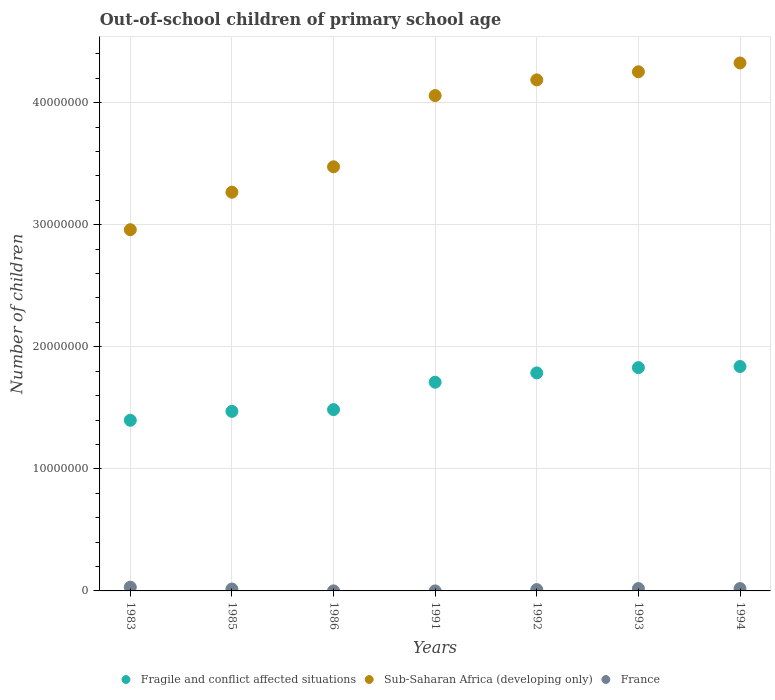How many different coloured dotlines are there?
Offer a terse response. 3. What is the number of out-of-school children in Sub-Saharan Africa (developing only) in 1993?
Offer a terse response. 4.25e+07. Across all years, what is the maximum number of out-of-school children in Sub-Saharan Africa (developing only)?
Your answer should be compact. 4.32e+07. Across all years, what is the minimum number of out-of-school children in France?
Provide a short and direct response. 245. What is the total number of out-of-school children in France in the graph?
Give a very brief answer. 9.63e+05. What is the difference between the number of out-of-school children in Sub-Saharan Africa (developing only) in 1983 and that in 1986?
Keep it short and to the point. -5.15e+06. What is the difference between the number of out-of-school children in Fragile and conflict affected situations in 1992 and the number of out-of-school children in France in 1983?
Give a very brief answer. 1.76e+07. What is the average number of out-of-school children in Sub-Saharan Africa (developing only) per year?
Keep it short and to the point. 3.79e+07. In the year 1991, what is the difference between the number of out-of-school children in Fragile and conflict affected situations and number of out-of-school children in France?
Your response must be concise. 1.71e+07. What is the ratio of the number of out-of-school children in Sub-Saharan Africa (developing only) in 1991 to that in 1992?
Make the answer very short. 0.97. What is the difference between the highest and the second highest number of out-of-school children in Sub-Saharan Africa (developing only)?
Your answer should be very brief. 7.20e+05. What is the difference between the highest and the lowest number of out-of-school children in Fragile and conflict affected situations?
Your response must be concise. 4.41e+06. In how many years, is the number of out-of-school children in Sub-Saharan Africa (developing only) greater than the average number of out-of-school children in Sub-Saharan Africa (developing only) taken over all years?
Your answer should be very brief. 4. Does the graph contain grids?
Your response must be concise. Yes. How are the legend labels stacked?
Offer a terse response. Horizontal. What is the title of the graph?
Keep it short and to the point. Out-of-school children of primary school age. Does "South Asia" appear as one of the legend labels in the graph?
Provide a short and direct response. No. What is the label or title of the X-axis?
Keep it short and to the point. Years. What is the label or title of the Y-axis?
Provide a succinct answer. Number of children. What is the Number of children in Fragile and conflict affected situations in 1983?
Make the answer very short. 1.40e+07. What is the Number of children in Sub-Saharan Africa (developing only) in 1983?
Provide a short and direct response. 2.96e+07. What is the Number of children in France in 1983?
Your response must be concise. 3.06e+05. What is the Number of children of Fragile and conflict affected situations in 1985?
Make the answer very short. 1.47e+07. What is the Number of children in Sub-Saharan Africa (developing only) in 1985?
Provide a short and direct response. 3.27e+07. What is the Number of children of France in 1985?
Provide a short and direct response. 1.56e+05. What is the Number of children in Fragile and conflict affected situations in 1986?
Offer a terse response. 1.49e+07. What is the Number of children in Sub-Saharan Africa (developing only) in 1986?
Offer a very short reply. 3.47e+07. What is the Number of children in France in 1986?
Your answer should be very brief. 2432. What is the Number of children in Fragile and conflict affected situations in 1991?
Provide a short and direct response. 1.71e+07. What is the Number of children of Sub-Saharan Africa (developing only) in 1991?
Offer a terse response. 4.06e+07. What is the Number of children in France in 1991?
Keep it short and to the point. 245. What is the Number of children in Fragile and conflict affected situations in 1992?
Your answer should be very brief. 1.79e+07. What is the Number of children of Sub-Saharan Africa (developing only) in 1992?
Keep it short and to the point. 4.19e+07. What is the Number of children of France in 1992?
Ensure brevity in your answer.  1.08e+05. What is the Number of children of Fragile and conflict affected situations in 1993?
Provide a succinct answer. 1.83e+07. What is the Number of children of Sub-Saharan Africa (developing only) in 1993?
Make the answer very short. 4.25e+07. What is the Number of children of France in 1993?
Your answer should be compact. 1.94e+05. What is the Number of children of Fragile and conflict affected situations in 1994?
Ensure brevity in your answer.  1.84e+07. What is the Number of children of Sub-Saharan Africa (developing only) in 1994?
Offer a terse response. 4.32e+07. What is the Number of children in France in 1994?
Provide a succinct answer. 1.96e+05. Across all years, what is the maximum Number of children in Fragile and conflict affected situations?
Offer a very short reply. 1.84e+07. Across all years, what is the maximum Number of children of Sub-Saharan Africa (developing only)?
Provide a succinct answer. 4.32e+07. Across all years, what is the maximum Number of children of France?
Provide a succinct answer. 3.06e+05. Across all years, what is the minimum Number of children in Fragile and conflict affected situations?
Keep it short and to the point. 1.40e+07. Across all years, what is the minimum Number of children of Sub-Saharan Africa (developing only)?
Give a very brief answer. 2.96e+07. Across all years, what is the minimum Number of children in France?
Ensure brevity in your answer.  245. What is the total Number of children of Fragile and conflict affected situations in the graph?
Make the answer very short. 1.15e+08. What is the total Number of children of Sub-Saharan Africa (developing only) in the graph?
Your answer should be compact. 2.65e+08. What is the total Number of children in France in the graph?
Give a very brief answer. 9.63e+05. What is the difference between the Number of children in Fragile and conflict affected situations in 1983 and that in 1985?
Provide a succinct answer. -7.29e+05. What is the difference between the Number of children in Sub-Saharan Africa (developing only) in 1983 and that in 1985?
Provide a succinct answer. -3.07e+06. What is the difference between the Number of children of France in 1983 and that in 1985?
Make the answer very short. 1.50e+05. What is the difference between the Number of children in Fragile and conflict affected situations in 1983 and that in 1986?
Ensure brevity in your answer.  -8.75e+05. What is the difference between the Number of children in Sub-Saharan Africa (developing only) in 1983 and that in 1986?
Your response must be concise. -5.15e+06. What is the difference between the Number of children in France in 1983 and that in 1986?
Your answer should be compact. 3.04e+05. What is the difference between the Number of children of Fragile and conflict affected situations in 1983 and that in 1991?
Your answer should be very brief. -3.12e+06. What is the difference between the Number of children of Sub-Saharan Africa (developing only) in 1983 and that in 1991?
Offer a very short reply. -1.10e+07. What is the difference between the Number of children of France in 1983 and that in 1991?
Offer a very short reply. 3.06e+05. What is the difference between the Number of children in Fragile and conflict affected situations in 1983 and that in 1992?
Make the answer very short. -3.88e+06. What is the difference between the Number of children of Sub-Saharan Africa (developing only) in 1983 and that in 1992?
Offer a very short reply. -1.23e+07. What is the difference between the Number of children of France in 1983 and that in 1992?
Offer a very short reply. 1.98e+05. What is the difference between the Number of children of Fragile and conflict affected situations in 1983 and that in 1993?
Keep it short and to the point. -4.31e+06. What is the difference between the Number of children in Sub-Saharan Africa (developing only) in 1983 and that in 1993?
Your response must be concise. -1.29e+07. What is the difference between the Number of children in France in 1983 and that in 1993?
Your response must be concise. 1.12e+05. What is the difference between the Number of children in Fragile and conflict affected situations in 1983 and that in 1994?
Offer a terse response. -4.41e+06. What is the difference between the Number of children in Sub-Saharan Africa (developing only) in 1983 and that in 1994?
Keep it short and to the point. -1.37e+07. What is the difference between the Number of children in France in 1983 and that in 1994?
Make the answer very short. 1.10e+05. What is the difference between the Number of children of Fragile and conflict affected situations in 1985 and that in 1986?
Ensure brevity in your answer.  -1.45e+05. What is the difference between the Number of children in Sub-Saharan Africa (developing only) in 1985 and that in 1986?
Keep it short and to the point. -2.08e+06. What is the difference between the Number of children in France in 1985 and that in 1986?
Ensure brevity in your answer.  1.54e+05. What is the difference between the Number of children in Fragile and conflict affected situations in 1985 and that in 1991?
Your answer should be very brief. -2.39e+06. What is the difference between the Number of children of Sub-Saharan Africa (developing only) in 1985 and that in 1991?
Ensure brevity in your answer.  -7.92e+06. What is the difference between the Number of children of France in 1985 and that in 1991?
Ensure brevity in your answer.  1.56e+05. What is the difference between the Number of children of Fragile and conflict affected situations in 1985 and that in 1992?
Your response must be concise. -3.15e+06. What is the difference between the Number of children of Sub-Saharan Africa (developing only) in 1985 and that in 1992?
Offer a terse response. -9.20e+06. What is the difference between the Number of children of France in 1985 and that in 1992?
Offer a very short reply. 4.80e+04. What is the difference between the Number of children of Fragile and conflict affected situations in 1985 and that in 1993?
Your response must be concise. -3.59e+06. What is the difference between the Number of children of Sub-Saharan Africa (developing only) in 1985 and that in 1993?
Keep it short and to the point. -9.87e+06. What is the difference between the Number of children of France in 1985 and that in 1993?
Your answer should be very brief. -3.82e+04. What is the difference between the Number of children in Fragile and conflict affected situations in 1985 and that in 1994?
Make the answer very short. -3.68e+06. What is the difference between the Number of children of Sub-Saharan Africa (developing only) in 1985 and that in 1994?
Offer a very short reply. -1.06e+07. What is the difference between the Number of children in France in 1985 and that in 1994?
Your response must be concise. -3.97e+04. What is the difference between the Number of children of Fragile and conflict affected situations in 1986 and that in 1991?
Your answer should be very brief. -2.24e+06. What is the difference between the Number of children in Sub-Saharan Africa (developing only) in 1986 and that in 1991?
Keep it short and to the point. -5.83e+06. What is the difference between the Number of children of France in 1986 and that in 1991?
Your answer should be compact. 2187. What is the difference between the Number of children in Fragile and conflict affected situations in 1986 and that in 1992?
Your answer should be compact. -3.01e+06. What is the difference between the Number of children in Sub-Saharan Africa (developing only) in 1986 and that in 1992?
Provide a succinct answer. -7.12e+06. What is the difference between the Number of children in France in 1986 and that in 1992?
Your answer should be very brief. -1.06e+05. What is the difference between the Number of children of Fragile and conflict affected situations in 1986 and that in 1993?
Your answer should be very brief. -3.44e+06. What is the difference between the Number of children in Sub-Saharan Africa (developing only) in 1986 and that in 1993?
Your response must be concise. -7.78e+06. What is the difference between the Number of children in France in 1986 and that in 1993?
Provide a short and direct response. -1.92e+05. What is the difference between the Number of children in Fragile and conflict affected situations in 1986 and that in 1994?
Provide a short and direct response. -3.53e+06. What is the difference between the Number of children of Sub-Saharan Africa (developing only) in 1986 and that in 1994?
Keep it short and to the point. -8.50e+06. What is the difference between the Number of children in France in 1986 and that in 1994?
Ensure brevity in your answer.  -1.93e+05. What is the difference between the Number of children in Fragile and conflict affected situations in 1991 and that in 1992?
Your answer should be very brief. -7.63e+05. What is the difference between the Number of children of Sub-Saharan Africa (developing only) in 1991 and that in 1992?
Make the answer very short. -1.28e+06. What is the difference between the Number of children of France in 1991 and that in 1992?
Keep it short and to the point. -1.08e+05. What is the difference between the Number of children in Fragile and conflict affected situations in 1991 and that in 1993?
Offer a very short reply. -1.20e+06. What is the difference between the Number of children of Sub-Saharan Africa (developing only) in 1991 and that in 1993?
Make the answer very short. -1.95e+06. What is the difference between the Number of children in France in 1991 and that in 1993?
Your answer should be very brief. -1.94e+05. What is the difference between the Number of children in Fragile and conflict affected situations in 1991 and that in 1994?
Your response must be concise. -1.29e+06. What is the difference between the Number of children in Sub-Saharan Africa (developing only) in 1991 and that in 1994?
Provide a succinct answer. -2.67e+06. What is the difference between the Number of children of France in 1991 and that in 1994?
Give a very brief answer. -1.96e+05. What is the difference between the Number of children in Fragile and conflict affected situations in 1992 and that in 1993?
Keep it short and to the point. -4.33e+05. What is the difference between the Number of children of Sub-Saharan Africa (developing only) in 1992 and that in 1993?
Keep it short and to the point. -6.66e+05. What is the difference between the Number of children of France in 1992 and that in 1993?
Provide a succinct answer. -8.62e+04. What is the difference between the Number of children in Fragile and conflict affected situations in 1992 and that in 1994?
Your answer should be compact. -5.24e+05. What is the difference between the Number of children of Sub-Saharan Africa (developing only) in 1992 and that in 1994?
Make the answer very short. -1.39e+06. What is the difference between the Number of children of France in 1992 and that in 1994?
Offer a terse response. -8.76e+04. What is the difference between the Number of children in Fragile and conflict affected situations in 1993 and that in 1994?
Offer a terse response. -9.04e+04. What is the difference between the Number of children in Sub-Saharan Africa (developing only) in 1993 and that in 1994?
Ensure brevity in your answer.  -7.20e+05. What is the difference between the Number of children of France in 1993 and that in 1994?
Keep it short and to the point. -1459. What is the difference between the Number of children of Fragile and conflict affected situations in 1983 and the Number of children of Sub-Saharan Africa (developing only) in 1985?
Your response must be concise. -1.87e+07. What is the difference between the Number of children of Fragile and conflict affected situations in 1983 and the Number of children of France in 1985?
Keep it short and to the point. 1.38e+07. What is the difference between the Number of children in Sub-Saharan Africa (developing only) in 1983 and the Number of children in France in 1985?
Your answer should be compact. 2.94e+07. What is the difference between the Number of children in Fragile and conflict affected situations in 1983 and the Number of children in Sub-Saharan Africa (developing only) in 1986?
Provide a succinct answer. -2.08e+07. What is the difference between the Number of children in Fragile and conflict affected situations in 1983 and the Number of children in France in 1986?
Your answer should be compact. 1.40e+07. What is the difference between the Number of children of Sub-Saharan Africa (developing only) in 1983 and the Number of children of France in 1986?
Your answer should be very brief. 2.96e+07. What is the difference between the Number of children of Fragile and conflict affected situations in 1983 and the Number of children of Sub-Saharan Africa (developing only) in 1991?
Offer a very short reply. -2.66e+07. What is the difference between the Number of children of Fragile and conflict affected situations in 1983 and the Number of children of France in 1991?
Provide a succinct answer. 1.40e+07. What is the difference between the Number of children of Sub-Saharan Africa (developing only) in 1983 and the Number of children of France in 1991?
Offer a terse response. 2.96e+07. What is the difference between the Number of children of Fragile and conflict affected situations in 1983 and the Number of children of Sub-Saharan Africa (developing only) in 1992?
Your answer should be compact. -2.79e+07. What is the difference between the Number of children of Fragile and conflict affected situations in 1983 and the Number of children of France in 1992?
Your answer should be very brief. 1.39e+07. What is the difference between the Number of children in Sub-Saharan Africa (developing only) in 1983 and the Number of children in France in 1992?
Offer a terse response. 2.95e+07. What is the difference between the Number of children in Fragile and conflict affected situations in 1983 and the Number of children in Sub-Saharan Africa (developing only) in 1993?
Ensure brevity in your answer.  -2.85e+07. What is the difference between the Number of children of Fragile and conflict affected situations in 1983 and the Number of children of France in 1993?
Your response must be concise. 1.38e+07. What is the difference between the Number of children of Sub-Saharan Africa (developing only) in 1983 and the Number of children of France in 1993?
Offer a terse response. 2.94e+07. What is the difference between the Number of children of Fragile and conflict affected situations in 1983 and the Number of children of Sub-Saharan Africa (developing only) in 1994?
Your response must be concise. -2.93e+07. What is the difference between the Number of children of Fragile and conflict affected situations in 1983 and the Number of children of France in 1994?
Provide a succinct answer. 1.38e+07. What is the difference between the Number of children of Sub-Saharan Africa (developing only) in 1983 and the Number of children of France in 1994?
Make the answer very short. 2.94e+07. What is the difference between the Number of children in Fragile and conflict affected situations in 1985 and the Number of children in Sub-Saharan Africa (developing only) in 1986?
Your answer should be very brief. -2.00e+07. What is the difference between the Number of children of Fragile and conflict affected situations in 1985 and the Number of children of France in 1986?
Keep it short and to the point. 1.47e+07. What is the difference between the Number of children of Sub-Saharan Africa (developing only) in 1985 and the Number of children of France in 1986?
Your response must be concise. 3.27e+07. What is the difference between the Number of children of Fragile and conflict affected situations in 1985 and the Number of children of Sub-Saharan Africa (developing only) in 1991?
Offer a very short reply. -2.59e+07. What is the difference between the Number of children of Fragile and conflict affected situations in 1985 and the Number of children of France in 1991?
Your answer should be very brief. 1.47e+07. What is the difference between the Number of children of Sub-Saharan Africa (developing only) in 1985 and the Number of children of France in 1991?
Your answer should be compact. 3.27e+07. What is the difference between the Number of children of Fragile and conflict affected situations in 1985 and the Number of children of Sub-Saharan Africa (developing only) in 1992?
Offer a terse response. -2.72e+07. What is the difference between the Number of children in Fragile and conflict affected situations in 1985 and the Number of children in France in 1992?
Offer a terse response. 1.46e+07. What is the difference between the Number of children in Sub-Saharan Africa (developing only) in 1985 and the Number of children in France in 1992?
Provide a short and direct response. 3.26e+07. What is the difference between the Number of children in Fragile and conflict affected situations in 1985 and the Number of children in Sub-Saharan Africa (developing only) in 1993?
Your answer should be very brief. -2.78e+07. What is the difference between the Number of children in Fragile and conflict affected situations in 1985 and the Number of children in France in 1993?
Your response must be concise. 1.45e+07. What is the difference between the Number of children of Sub-Saharan Africa (developing only) in 1985 and the Number of children of France in 1993?
Ensure brevity in your answer.  3.25e+07. What is the difference between the Number of children in Fragile and conflict affected situations in 1985 and the Number of children in Sub-Saharan Africa (developing only) in 1994?
Make the answer very short. -2.85e+07. What is the difference between the Number of children of Fragile and conflict affected situations in 1985 and the Number of children of France in 1994?
Make the answer very short. 1.45e+07. What is the difference between the Number of children of Sub-Saharan Africa (developing only) in 1985 and the Number of children of France in 1994?
Offer a terse response. 3.25e+07. What is the difference between the Number of children in Fragile and conflict affected situations in 1986 and the Number of children in Sub-Saharan Africa (developing only) in 1991?
Give a very brief answer. -2.57e+07. What is the difference between the Number of children of Fragile and conflict affected situations in 1986 and the Number of children of France in 1991?
Keep it short and to the point. 1.49e+07. What is the difference between the Number of children in Sub-Saharan Africa (developing only) in 1986 and the Number of children in France in 1991?
Your response must be concise. 3.47e+07. What is the difference between the Number of children of Fragile and conflict affected situations in 1986 and the Number of children of Sub-Saharan Africa (developing only) in 1992?
Your answer should be very brief. -2.70e+07. What is the difference between the Number of children in Fragile and conflict affected situations in 1986 and the Number of children in France in 1992?
Offer a very short reply. 1.47e+07. What is the difference between the Number of children in Sub-Saharan Africa (developing only) in 1986 and the Number of children in France in 1992?
Give a very brief answer. 3.46e+07. What is the difference between the Number of children of Fragile and conflict affected situations in 1986 and the Number of children of Sub-Saharan Africa (developing only) in 1993?
Your answer should be very brief. -2.77e+07. What is the difference between the Number of children of Fragile and conflict affected situations in 1986 and the Number of children of France in 1993?
Offer a very short reply. 1.47e+07. What is the difference between the Number of children in Sub-Saharan Africa (developing only) in 1986 and the Number of children in France in 1993?
Your answer should be very brief. 3.46e+07. What is the difference between the Number of children in Fragile and conflict affected situations in 1986 and the Number of children in Sub-Saharan Africa (developing only) in 1994?
Keep it short and to the point. -2.84e+07. What is the difference between the Number of children of Fragile and conflict affected situations in 1986 and the Number of children of France in 1994?
Provide a succinct answer. 1.47e+07. What is the difference between the Number of children in Sub-Saharan Africa (developing only) in 1986 and the Number of children in France in 1994?
Provide a succinct answer. 3.45e+07. What is the difference between the Number of children of Fragile and conflict affected situations in 1991 and the Number of children of Sub-Saharan Africa (developing only) in 1992?
Make the answer very short. -2.48e+07. What is the difference between the Number of children of Fragile and conflict affected situations in 1991 and the Number of children of France in 1992?
Keep it short and to the point. 1.70e+07. What is the difference between the Number of children of Sub-Saharan Africa (developing only) in 1991 and the Number of children of France in 1992?
Provide a short and direct response. 4.05e+07. What is the difference between the Number of children in Fragile and conflict affected situations in 1991 and the Number of children in Sub-Saharan Africa (developing only) in 1993?
Offer a very short reply. -2.54e+07. What is the difference between the Number of children in Fragile and conflict affected situations in 1991 and the Number of children in France in 1993?
Provide a short and direct response. 1.69e+07. What is the difference between the Number of children of Sub-Saharan Africa (developing only) in 1991 and the Number of children of France in 1993?
Provide a short and direct response. 4.04e+07. What is the difference between the Number of children of Fragile and conflict affected situations in 1991 and the Number of children of Sub-Saharan Africa (developing only) in 1994?
Ensure brevity in your answer.  -2.62e+07. What is the difference between the Number of children in Fragile and conflict affected situations in 1991 and the Number of children in France in 1994?
Your answer should be compact. 1.69e+07. What is the difference between the Number of children in Sub-Saharan Africa (developing only) in 1991 and the Number of children in France in 1994?
Keep it short and to the point. 4.04e+07. What is the difference between the Number of children of Fragile and conflict affected situations in 1992 and the Number of children of Sub-Saharan Africa (developing only) in 1993?
Ensure brevity in your answer.  -2.47e+07. What is the difference between the Number of children of Fragile and conflict affected situations in 1992 and the Number of children of France in 1993?
Keep it short and to the point. 1.77e+07. What is the difference between the Number of children of Sub-Saharan Africa (developing only) in 1992 and the Number of children of France in 1993?
Make the answer very short. 4.17e+07. What is the difference between the Number of children in Fragile and conflict affected situations in 1992 and the Number of children in Sub-Saharan Africa (developing only) in 1994?
Your answer should be very brief. -2.54e+07. What is the difference between the Number of children of Fragile and conflict affected situations in 1992 and the Number of children of France in 1994?
Ensure brevity in your answer.  1.77e+07. What is the difference between the Number of children in Sub-Saharan Africa (developing only) in 1992 and the Number of children in France in 1994?
Your answer should be compact. 4.17e+07. What is the difference between the Number of children in Fragile and conflict affected situations in 1993 and the Number of children in Sub-Saharan Africa (developing only) in 1994?
Make the answer very short. -2.50e+07. What is the difference between the Number of children in Fragile and conflict affected situations in 1993 and the Number of children in France in 1994?
Provide a short and direct response. 1.81e+07. What is the difference between the Number of children in Sub-Saharan Africa (developing only) in 1993 and the Number of children in France in 1994?
Ensure brevity in your answer.  4.23e+07. What is the average Number of children in Fragile and conflict affected situations per year?
Offer a very short reply. 1.65e+07. What is the average Number of children in Sub-Saharan Africa (developing only) per year?
Keep it short and to the point. 3.79e+07. What is the average Number of children in France per year?
Give a very brief answer. 1.38e+05. In the year 1983, what is the difference between the Number of children of Fragile and conflict affected situations and Number of children of Sub-Saharan Africa (developing only)?
Offer a terse response. -1.56e+07. In the year 1983, what is the difference between the Number of children in Fragile and conflict affected situations and Number of children in France?
Provide a succinct answer. 1.37e+07. In the year 1983, what is the difference between the Number of children in Sub-Saharan Africa (developing only) and Number of children in France?
Your answer should be very brief. 2.93e+07. In the year 1985, what is the difference between the Number of children of Fragile and conflict affected situations and Number of children of Sub-Saharan Africa (developing only)?
Ensure brevity in your answer.  -1.80e+07. In the year 1985, what is the difference between the Number of children of Fragile and conflict affected situations and Number of children of France?
Your response must be concise. 1.46e+07. In the year 1985, what is the difference between the Number of children of Sub-Saharan Africa (developing only) and Number of children of France?
Ensure brevity in your answer.  3.25e+07. In the year 1986, what is the difference between the Number of children in Fragile and conflict affected situations and Number of children in Sub-Saharan Africa (developing only)?
Ensure brevity in your answer.  -1.99e+07. In the year 1986, what is the difference between the Number of children of Fragile and conflict affected situations and Number of children of France?
Provide a short and direct response. 1.49e+07. In the year 1986, what is the difference between the Number of children in Sub-Saharan Africa (developing only) and Number of children in France?
Provide a short and direct response. 3.47e+07. In the year 1991, what is the difference between the Number of children in Fragile and conflict affected situations and Number of children in Sub-Saharan Africa (developing only)?
Give a very brief answer. -2.35e+07. In the year 1991, what is the difference between the Number of children of Fragile and conflict affected situations and Number of children of France?
Make the answer very short. 1.71e+07. In the year 1991, what is the difference between the Number of children in Sub-Saharan Africa (developing only) and Number of children in France?
Your response must be concise. 4.06e+07. In the year 1992, what is the difference between the Number of children of Fragile and conflict affected situations and Number of children of Sub-Saharan Africa (developing only)?
Offer a terse response. -2.40e+07. In the year 1992, what is the difference between the Number of children of Fragile and conflict affected situations and Number of children of France?
Your response must be concise. 1.78e+07. In the year 1992, what is the difference between the Number of children of Sub-Saharan Africa (developing only) and Number of children of France?
Make the answer very short. 4.18e+07. In the year 1993, what is the difference between the Number of children of Fragile and conflict affected situations and Number of children of Sub-Saharan Africa (developing only)?
Your answer should be very brief. -2.42e+07. In the year 1993, what is the difference between the Number of children in Fragile and conflict affected situations and Number of children in France?
Keep it short and to the point. 1.81e+07. In the year 1993, what is the difference between the Number of children in Sub-Saharan Africa (developing only) and Number of children in France?
Give a very brief answer. 4.23e+07. In the year 1994, what is the difference between the Number of children in Fragile and conflict affected situations and Number of children in Sub-Saharan Africa (developing only)?
Make the answer very short. -2.49e+07. In the year 1994, what is the difference between the Number of children of Fragile and conflict affected situations and Number of children of France?
Give a very brief answer. 1.82e+07. In the year 1994, what is the difference between the Number of children of Sub-Saharan Africa (developing only) and Number of children of France?
Ensure brevity in your answer.  4.31e+07. What is the ratio of the Number of children in Fragile and conflict affected situations in 1983 to that in 1985?
Your answer should be very brief. 0.95. What is the ratio of the Number of children of Sub-Saharan Africa (developing only) in 1983 to that in 1985?
Your response must be concise. 0.91. What is the ratio of the Number of children of France in 1983 to that in 1985?
Offer a terse response. 1.96. What is the ratio of the Number of children in Fragile and conflict affected situations in 1983 to that in 1986?
Offer a very short reply. 0.94. What is the ratio of the Number of children in Sub-Saharan Africa (developing only) in 1983 to that in 1986?
Your response must be concise. 0.85. What is the ratio of the Number of children of France in 1983 to that in 1986?
Provide a short and direct response. 125.91. What is the ratio of the Number of children in Fragile and conflict affected situations in 1983 to that in 1991?
Make the answer very short. 0.82. What is the ratio of the Number of children of Sub-Saharan Africa (developing only) in 1983 to that in 1991?
Your response must be concise. 0.73. What is the ratio of the Number of children in France in 1983 to that in 1991?
Make the answer very short. 1249.9. What is the ratio of the Number of children of Fragile and conflict affected situations in 1983 to that in 1992?
Your answer should be compact. 0.78. What is the ratio of the Number of children of Sub-Saharan Africa (developing only) in 1983 to that in 1992?
Provide a succinct answer. 0.71. What is the ratio of the Number of children of France in 1983 to that in 1992?
Your response must be concise. 2.83. What is the ratio of the Number of children in Fragile and conflict affected situations in 1983 to that in 1993?
Your answer should be very brief. 0.76. What is the ratio of the Number of children in Sub-Saharan Africa (developing only) in 1983 to that in 1993?
Ensure brevity in your answer.  0.7. What is the ratio of the Number of children in France in 1983 to that in 1993?
Your answer should be very brief. 1.58. What is the ratio of the Number of children of Fragile and conflict affected situations in 1983 to that in 1994?
Your answer should be compact. 0.76. What is the ratio of the Number of children of Sub-Saharan Africa (developing only) in 1983 to that in 1994?
Your answer should be very brief. 0.68. What is the ratio of the Number of children of France in 1983 to that in 1994?
Keep it short and to the point. 1.56. What is the ratio of the Number of children of Fragile and conflict affected situations in 1985 to that in 1986?
Ensure brevity in your answer.  0.99. What is the ratio of the Number of children of Sub-Saharan Africa (developing only) in 1985 to that in 1986?
Give a very brief answer. 0.94. What is the ratio of the Number of children in France in 1985 to that in 1986?
Offer a terse response. 64.2. What is the ratio of the Number of children in Fragile and conflict affected situations in 1985 to that in 1991?
Give a very brief answer. 0.86. What is the ratio of the Number of children of Sub-Saharan Africa (developing only) in 1985 to that in 1991?
Your answer should be very brief. 0.8. What is the ratio of the Number of children in France in 1985 to that in 1991?
Give a very brief answer. 637.3. What is the ratio of the Number of children in Fragile and conflict affected situations in 1985 to that in 1992?
Make the answer very short. 0.82. What is the ratio of the Number of children in Sub-Saharan Africa (developing only) in 1985 to that in 1992?
Keep it short and to the point. 0.78. What is the ratio of the Number of children in France in 1985 to that in 1992?
Your answer should be compact. 1.44. What is the ratio of the Number of children in Fragile and conflict affected situations in 1985 to that in 1993?
Give a very brief answer. 0.8. What is the ratio of the Number of children of Sub-Saharan Africa (developing only) in 1985 to that in 1993?
Your answer should be very brief. 0.77. What is the ratio of the Number of children in France in 1985 to that in 1993?
Offer a very short reply. 0.8. What is the ratio of the Number of children of Fragile and conflict affected situations in 1985 to that in 1994?
Provide a succinct answer. 0.8. What is the ratio of the Number of children in Sub-Saharan Africa (developing only) in 1985 to that in 1994?
Your answer should be very brief. 0.76. What is the ratio of the Number of children of France in 1985 to that in 1994?
Provide a short and direct response. 0.8. What is the ratio of the Number of children of Fragile and conflict affected situations in 1986 to that in 1991?
Your answer should be compact. 0.87. What is the ratio of the Number of children of Sub-Saharan Africa (developing only) in 1986 to that in 1991?
Your answer should be compact. 0.86. What is the ratio of the Number of children of France in 1986 to that in 1991?
Offer a very short reply. 9.93. What is the ratio of the Number of children in Fragile and conflict affected situations in 1986 to that in 1992?
Your answer should be very brief. 0.83. What is the ratio of the Number of children of Sub-Saharan Africa (developing only) in 1986 to that in 1992?
Make the answer very short. 0.83. What is the ratio of the Number of children in France in 1986 to that in 1992?
Your response must be concise. 0.02. What is the ratio of the Number of children in Fragile and conflict affected situations in 1986 to that in 1993?
Provide a short and direct response. 0.81. What is the ratio of the Number of children of Sub-Saharan Africa (developing only) in 1986 to that in 1993?
Your answer should be very brief. 0.82. What is the ratio of the Number of children of France in 1986 to that in 1993?
Keep it short and to the point. 0.01. What is the ratio of the Number of children in Fragile and conflict affected situations in 1986 to that in 1994?
Give a very brief answer. 0.81. What is the ratio of the Number of children of Sub-Saharan Africa (developing only) in 1986 to that in 1994?
Provide a succinct answer. 0.8. What is the ratio of the Number of children of France in 1986 to that in 1994?
Your response must be concise. 0.01. What is the ratio of the Number of children of Fragile and conflict affected situations in 1991 to that in 1992?
Your response must be concise. 0.96. What is the ratio of the Number of children in Sub-Saharan Africa (developing only) in 1991 to that in 1992?
Offer a very short reply. 0.97. What is the ratio of the Number of children in France in 1991 to that in 1992?
Ensure brevity in your answer.  0. What is the ratio of the Number of children of Fragile and conflict affected situations in 1991 to that in 1993?
Make the answer very short. 0.93. What is the ratio of the Number of children of Sub-Saharan Africa (developing only) in 1991 to that in 1993?
Offer a terse response. 0.95. What is the ratio of the Number of children of France in 1991 to that in 1993?
Your response must be concise. 0. What is the ratio of the Number of children in Fragile and conflict affected situations in 1991 to that in 1994?
Provide a succinct answer. 0.93. What is the ratio of the Number of children in Sub-Saharan Africa (developing only) in 1991 to that in 1994?
Your answer should be very brief. 0.94. What is the ratio of the Number of children in France in 1991 to that in 1994?
Your answer should be compact. 0. What is the ratio of the Number of children of Fragile and conflict affected situations in 1992 to that in 1993?
Offer a terse response. 0.98. What is the ratio of the Number of children in Sub-Saharan Africa (developing only) in 1992 to that in 1993?
Keep it short and to the point. 0.98. What is the ratio of the Number of children of France in 1992 to that in 1993?
Offer a terse response. 0.56. What is the ratio of the Number of children of Fragile and conflict affected situations in 1992 to that in 1994?
Offer a very short reply. 0.97. What is the ratio of the Number of children of France in 1992 to that in 1994?
Provide a short and direct response. 0.55. What is the ratio of the Number of children of Sub-Saharan Africa (developing only) in 1993 to that in 1994?
Offer a very short reply. 0.98. What is the ratio of the Number of children of France in 1993 to that in 1994?
Provide a short and direct response. 0.99. What is the difference between the highest and the second highest Number of children in Fragile and conflict affected situations?
Offer a very short reply. 9.04e+04. What is the difference between the highest and the second highest Number of children in Sub-Saharan Africa (developing only)?
Provide a succinct answer. 7.20e+05. What is the difference between the highest and the second highest Number of children of France?
Provide a succinct answer. 1.10e+05. What is the difference between the highest and the lowest Number of children of Fragile and conflict affected situations?
Your response must be concise. 4.41e+06. What is the difference between the highest and the lowest Number of children in Sub-Saharan Africa (developing only)?
Ensure brevity in your answer.  1.37e+07. What is the difference between the highest and the lowest Number of children in France?
Your answer should be very brief. 3.06e+05. 